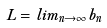Convert formula to latex. <formula><loc_0><loc_0><loc_500><loc_500>L = l i m _ { n \rightarrow \infty } b _ { n }</formula> 